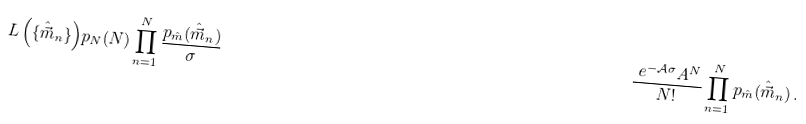Convert formula to latex. <formula><loc_0><loc_0><loc_500><loc_500>L \left ( \{ \hat { \vec { m } } _ { n } \} \right ) & p _ { N } ( N ) \prod _ { n = 1 } ^ { N } \frac { p _ { \hat { m } } ( \hat { \vec { m } } _ { n } ) } { \sigma } & \frac { \ e ^ { - \mathcal { A } \sigma } A ^ { N } } { N ! } \prod _ { n = 1 } ^ { N } p _ { \hat { m } } ( \hat { \vec { m } } _ { n } ) \, .</formula> 